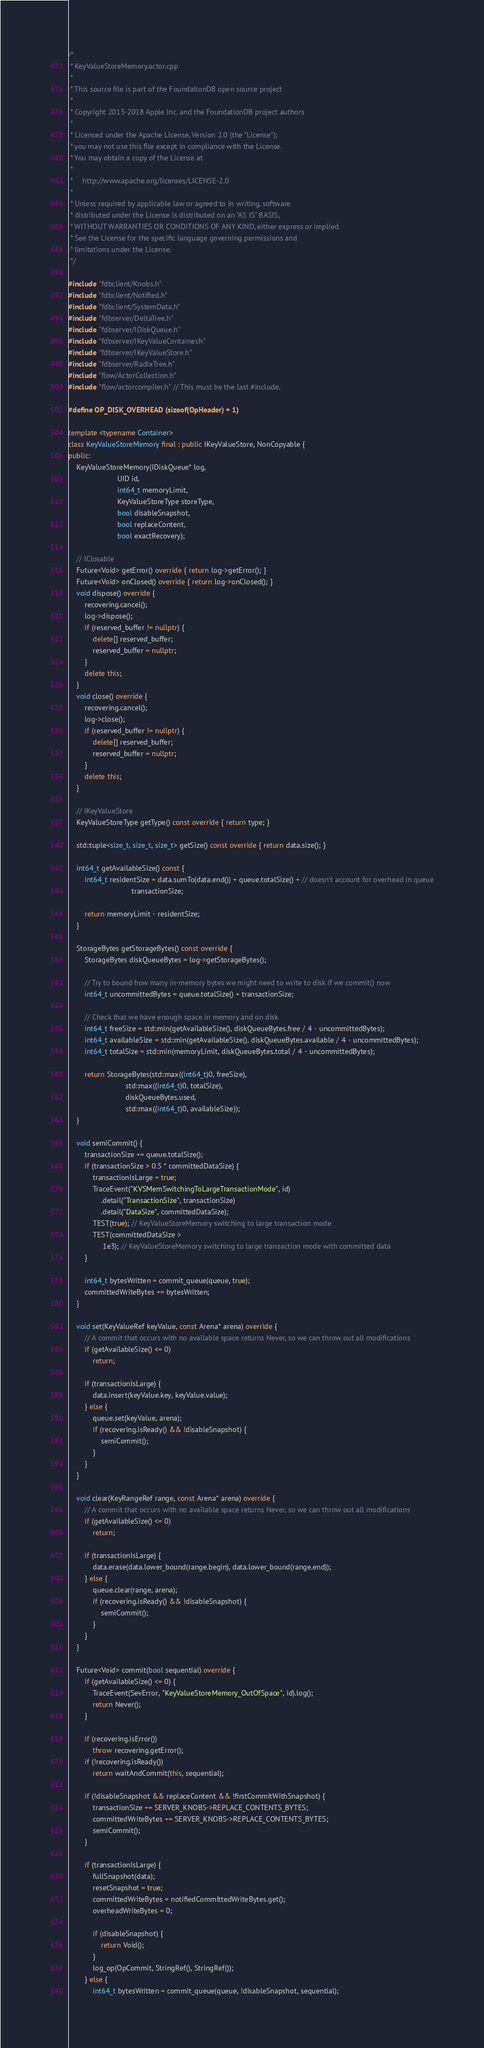Convert code to text. <code><loc_0><loc_0><loc_500><loc_500><_C++_>/*
 * KeyValueStoreMemory.actor.cpp
 *
 * This source file is part of the FoundationDB open source project
 *
 * Copyright 2013-2018 Apple Inc. and the FoundationDB project authors
 *
 * Licensed under the Apache License, Version 2.0 (the "License");
 * you may not use this file except in compliance with the License.
 * You may obtain a copy of the License at
 *
 *     http://www.apache.org/licenses/LICENSE-2.0
 *
 * Unless required by applicable law or agreed to in writing, software
 * distributed under the License is distributed on an "AS IS" BASIS,
 * WITHOUT WARRANTIES OR CONDITIONS OF ANY KIND, either express or implied.
 * See the License for the specific language governing permissions and
 * limitations under the License.
 */

#include "fdbclient/Knobs.h"
#include "fdbclient/Notified.h"
#include "fdbclient/SystemData.h"
#include "fdbserver/DeltaTree.h"
#include "fdbserver/IDiskQueue.h"
#include "fdbserver/IKeyValueContainer.h"
#include "fdbserver/IKeyValueStore.h"
#include "fdbserver/RadixTree.h"
#include "flow/ActorCollection.h"
#include "flow/actorcompiler.h" // This must be the last #include.

#define OP_DISK_OVERHEAD (sizeof(OpHeader) + 1)

template <typename Container>
class KeyValueStoreMemory final : public IKeyValueStore, NonCopyable {
public:
	KeyValueStoreMemory(IDiskQueue* log,
	                    UID id,
	                    int64_t memoryLimit,
	                    KeyValueStoreType storeType,
	                    bool disableSnapshot,
	                    bool replaceContent,
	                    bool exactRecovery);

	// IClosable
	Future<Void> getError() override { return log->getError(); }
	Future<Void> onClosed() override { return log->onClosed(); }
	void dispose() override {
		recovering.cancel();
		log->dispose();
		if (reserved_buffer != nullptr) {
			delete[] reserved_buffer;
			reserved_buffer = nullptr;
		}
		delete this;
	}
	void close() override {
		recovering.cancel();
		log->close();
		if (reserved_buffer != nullptr) {
			delete[] reserved_buffer;
			reserved_buffer = nullptr;
		}
		delete this;
	}

	// IKeyValueStore
	KeyValueStoreType getType() const override { return type; }

	std::tuple<size_t, size_t, size_t> getSize() const override { return data.size(); }

	int64_t getAvailableSize() const {
		int64_t residentSize = data.sumTo(data.end()) + queue.totalSize() + // doesn't account for overhead in queue
		                       transactionSize;

		return memoryLimit - residentSize;
	}

	StorageBytes getStorageBytes() const override {
		StorageBytes diskQueueBytes = log->getStorageBytes();

		// Try to bound how many in-memory bytes we might need to write to disk if we commit() now
		int64_t uncommittedBytes = queue.totalSize() + transactionSize;

		// Check that we have enough space in memory and on disk
		int64_t freeSize = std::min(getAvailableSize(), diskQueueBytes.free / 4 - uncommittedBytes);
		int64_t availableSize = std::min(getAvailableSize(), diskQueueBytes.available / 4 - uncommittedBytes);
		int64_t totalSize = std::min(memoryLimit, diskQueueBytes.total / 4 - uncommittedBytes);

		return StorageBytes(std::max((int64_t)0, freeSize),
		                    std::max((int64_t)0, totalSize),
		                    diskQueueBytes.used,
		                    std::max((int64_t)0, availableSize));
	}

	void semiCommit() {
		transactionSize += queue.totalSize();
		if (transactionSize > 0.5 * committedDataSize) {
			transactionIsLarge = true;
			TraceEvent("KVSMemSwitchingToLargeTransactionMode", id)
			    .detail("TransactionSize", transactionSize)
			    .detail("DataSize", committedDataSize);
			TEST(true); // KeyValueStoreMemory switching to large transaction mode
			TEST(committedDataSize >
			     1e3); // KeyValueStoreMemory switching to large transaction mode with committed data
		}

		int64_t bytesWritten = commit_queue(queue, true);
		committedWriteBytes += bytesWritten;
	}

	void set(KeyValueRef keyValue, const Arena* arena) override {
		// A commit that occurs with no available space returns Never, so we can throw out all modifications
		if (getAvailableSize() <= 0)
			return;

		if (transactionIsLarge) {
			data.insert(keyValue.key, keyValue.value);
		} else {
			queue.set(keyValue, arena);
			if (recovering.isReady() && !disableSnapshot) {
				semiCommit();
			}
		}
	}

	void clear(KeyRangeRef range, const Arena* arena) override {
		// A commit that occurs with no available space returns Never, so we can throw out all modifications
		if (getAvailableSize() <= 0)
			return;

		if (transactionIsLarge) {
			data.erase(data.lower_bound(range.begin), data.lower_bound(range.end));
		} else {
			queue.clear(range, arena);
			if (recovering.isReady() && !disableSnapshot) {
				semiCommit();
			}
		}
	}

	Future<Void> commit(bool sequential) override {
		if (getAvailableSize() <= 0) {
			TraceEvent(SevError, "KeyValueStoreMemory_OutOfSpace", id).log();
			return Never();
		}

		if (recovering.isError())
			throw recovering.getError();
		if (!recovering.isReady())
			return waitAndCommit(this, sequential);

		if (!disableSnapshot && replaceContent && !firstCommitWithSnapshot) {
			transactionSize += SERVER_KNOBS->REPLACE_CONTENTS_BYTES;
			committedWriteBytes += SERVER_KNOBS->REPLACE_CONTENTS_BYTES;
			semiCommit();
		}

		if (transactionIsLarge) {
			fullSnapshot(data);
			resetSnapshot = true;
			committedWriteBytes = notifiedCommittedWriteBytes.get();
			overheadWriteBytes = 0;

			if (disableSnapshot) {
				return Void();
			}
			log_op(OpCommit, StringRef(), StringRef());
		} else {
			int64_t bytesWritten = commit_queue(queue, !disableSnapshot, sequential);
</code> 